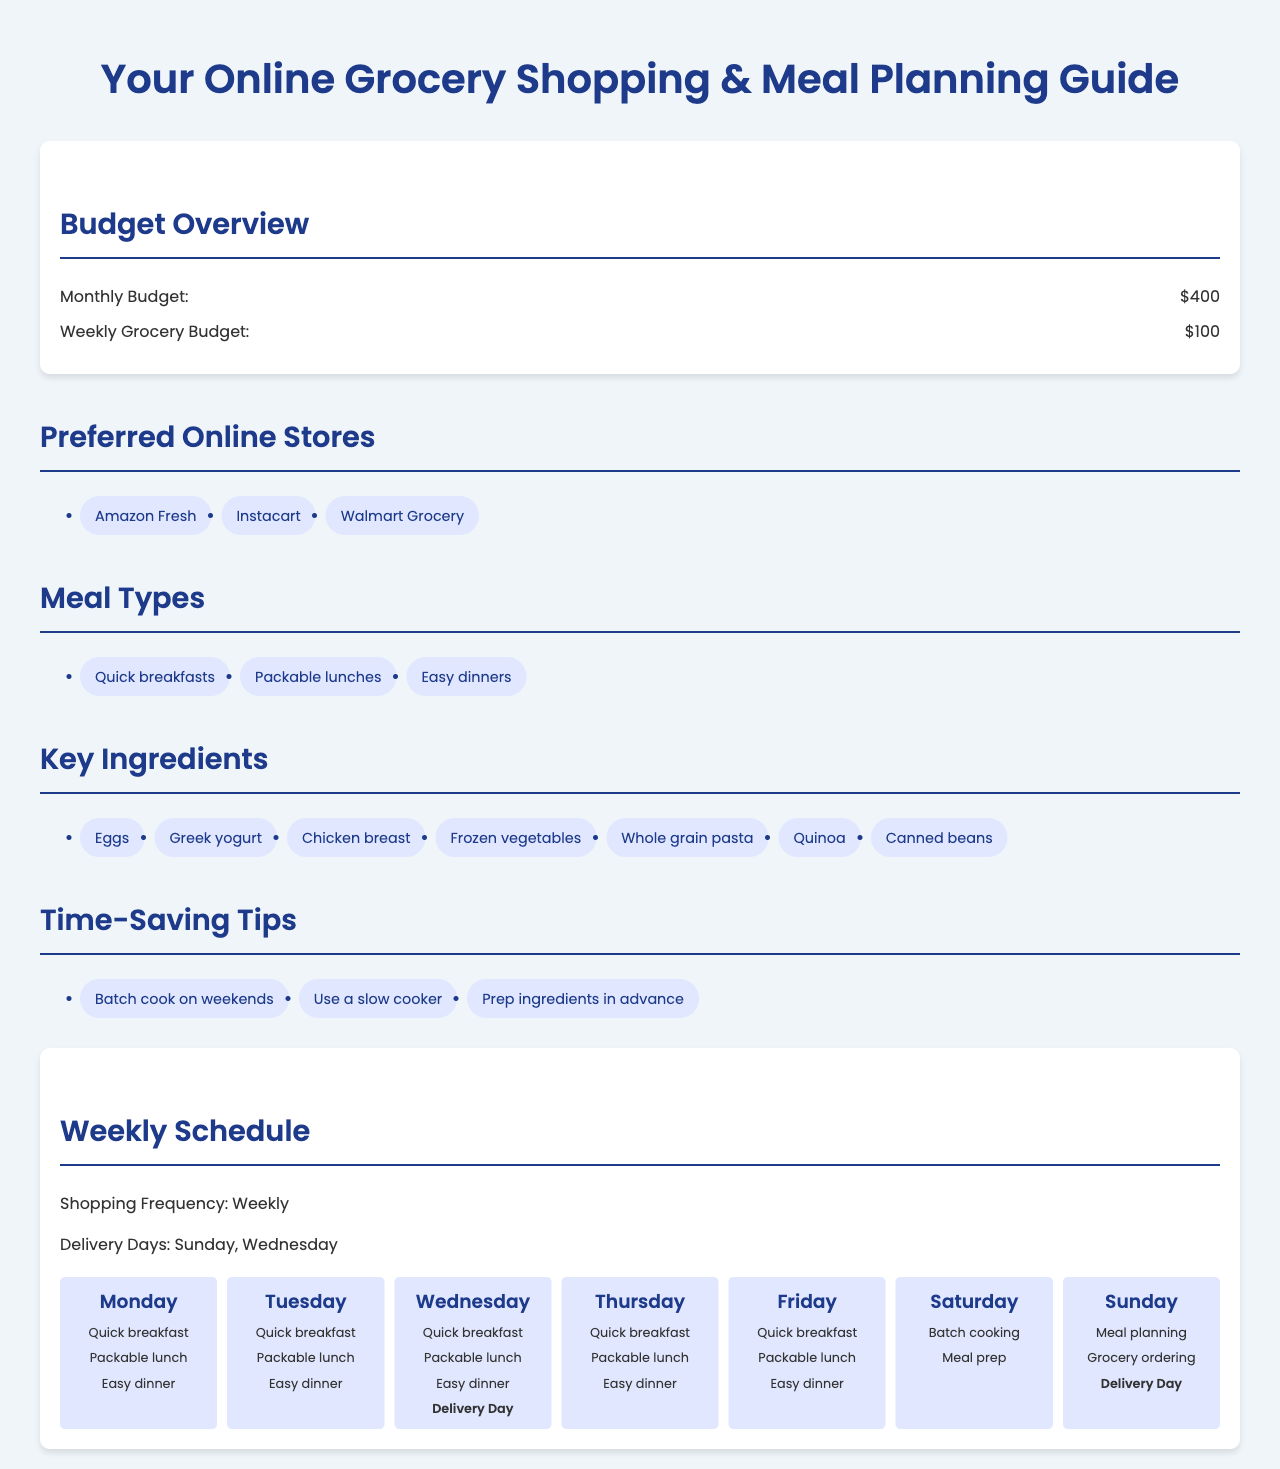What is the monthly budget? The monthly budget is stated in the document as $400.
Answer: $400 How many preferred online stores are listed? The document lists three preferred online stores.
Answer: 3 What type of meal is scheduled for Saturday? On Saturday, the schedule indicates "Batch cooking."
Answer: Batch cooking What is the shopping frequency? The document mentions that the shopping frequency is "Weekly."
Answer: Weekly Which day has a grocery delivery? The document states that deliveries occur on Sunday and Wednesday.
Answer: Sunday, Wednesday What is one of the time-saving tips? The document includes several time-saving tips, one of which is "Batch cook on weekends."
Answer: Batch cook on weekends What is the weekly grocery budget? The weekly grocery budget is specified as $100.
Answer: $100 What type of dinner is planned for every weekday? The document specifies "Easy dinner" for each weekday.
Answer: Easy dinner 